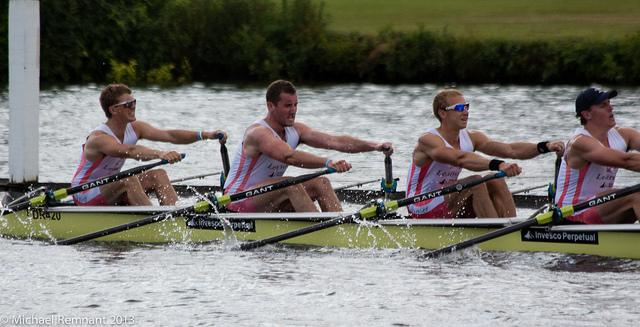Who are these people to each other?

Choices:
A) allies
B) teammates
C) relatives
D) enemies teammates 